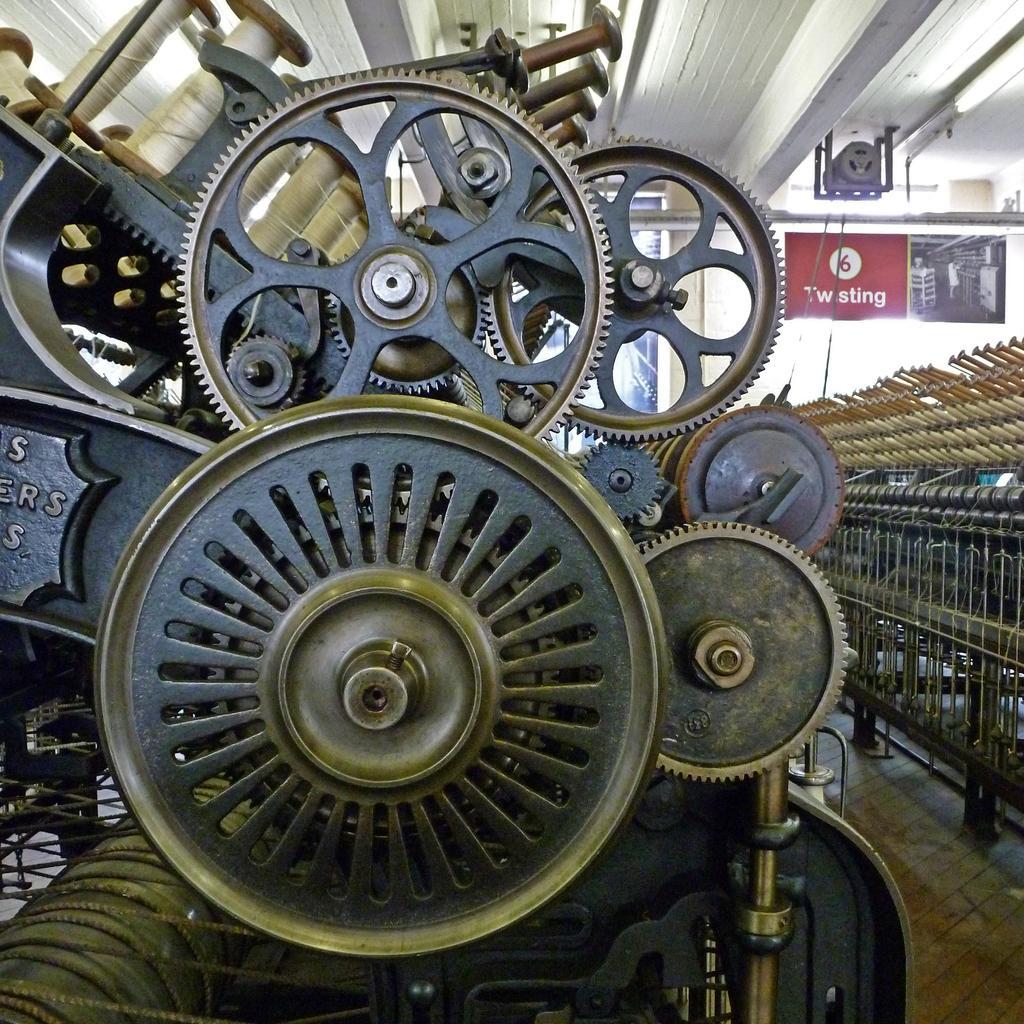Can you describe this image briefly? In this picture I can see there is a rotor and there is a equipment on to left side and there are few objects on to right side and there is a door in the backdrop. 